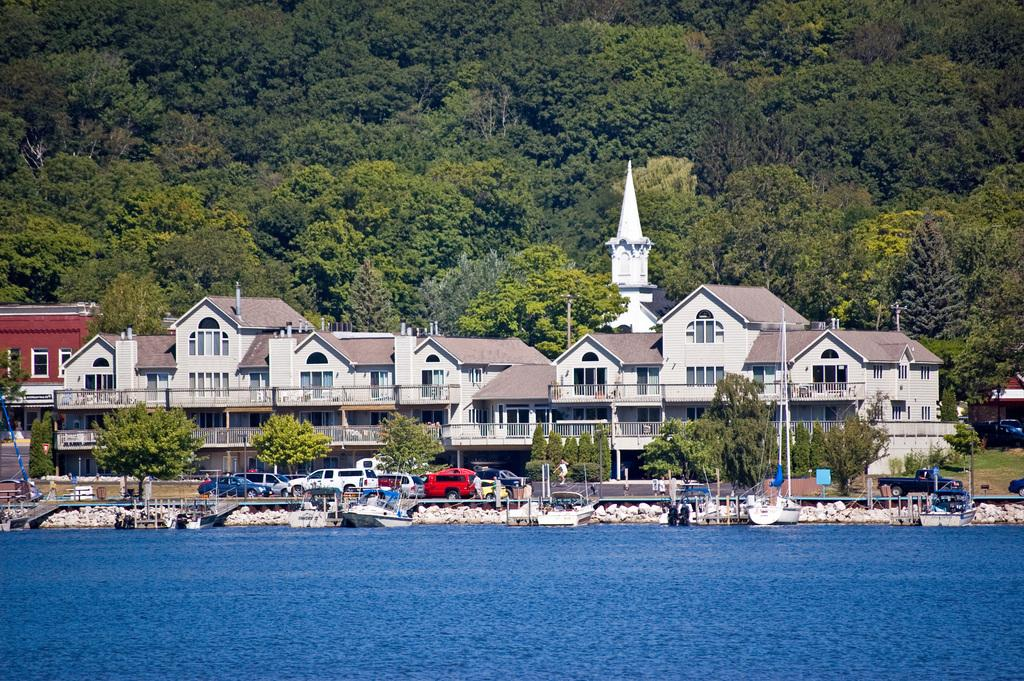What type of structures can be seen in the image? There are buildings in the image. What is used for cooking in the image? There are grills in the image. What are the tall, thin objects in the image? There are poles in the image. What type of transportation is present in the image? There are motor vehicles in the image. What type of vehicles are on the water in the image? There are ships at the deck in the image. What natural elements can be seen in the image? There are rocks and trees in the image. To produce the conversation, we first identify the main subjects and objects in the image based on the provided facts. We then formulate questions that focus on the location and characteristics of these subjects and objects, ensuring that each question can be answered definitively with the information given. We avoid yes/no questions and ensure that the language is simple and clear. Absurd Question/Answer: What type of legal advice is the lawyer providing in the image? There is no lawyer present in the image, so it is not possible to determine what legal advice might be provided. What substance is being used to strengthen the beam in the image? There is no beam present in the image, so it is not possible to determine what substance might be used to strengthen it. What type of legal advice is the lawyer providing in the image? There is no lawyer present in the image, so it is not possible to determine what legal advice might be provided. What substance is being used to strengthen the beam in the image? There is no beam present in the image, so it is not possible to determine what substance might be used to strengthen it. 